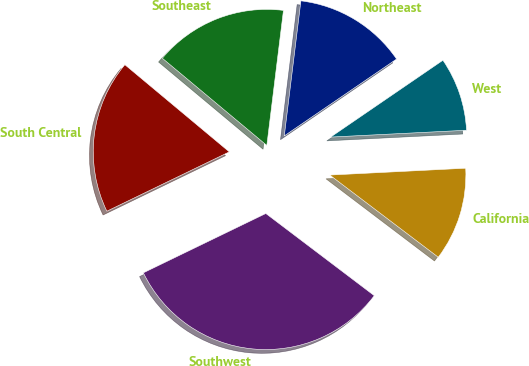<chart> <loc_0><loc_0><loc_500><loc_500><pie_chart><fcel>Northeast<fcel>Southeast<fcel>South Central<fcel>Southwest<fcel>California<fcel>West<nl><fcel>13.5%<fcel>15.88%<fcel>18.25%<fcel>32.5%<fcel>11.12%<fcel>8.75%<nl></chart> 